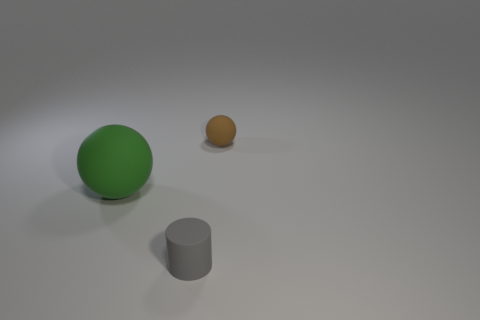Add 2 large cyan spheres. How many objects exist? 5 Subtract all balls. How many objects are left? 1 Add 3 large green spheres. How many large green spheres are left? 4 Add 3 green things. How many green things exist? 4 Subtract 0 blue balls. How many objects are left? 3 Subtract all gray matte blocks. Subtract all small gray matte objects. How many objects are left? 2 